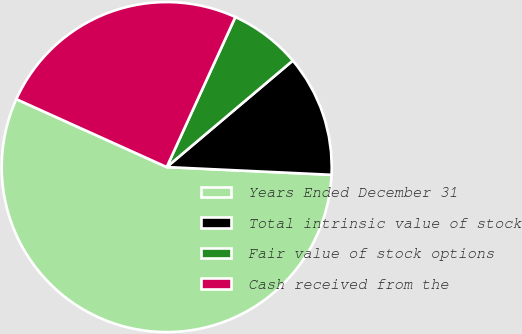<chart> <loc_0><loc_0><loc_500><loc_500><pie_chart><fcel>Years Ended December 31<fcel>Total intrinsic value of stock<fcel>Fair value of stock options<fcel>Cash received from the<nl><fcel>56.01%<fcel>11.91%<fcel>7.01%<fcel>25.08%<nl></chart> 